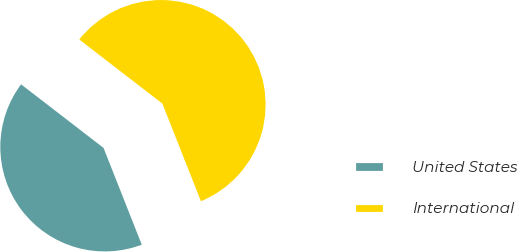Convert chart to OTSL. <chart><loc_0><loc_0><loc_500><loc_500><pie_chart><fcel>United States<fcel>International<nl><fcel>41.44%<fcel>58.56%<nl></chart> 